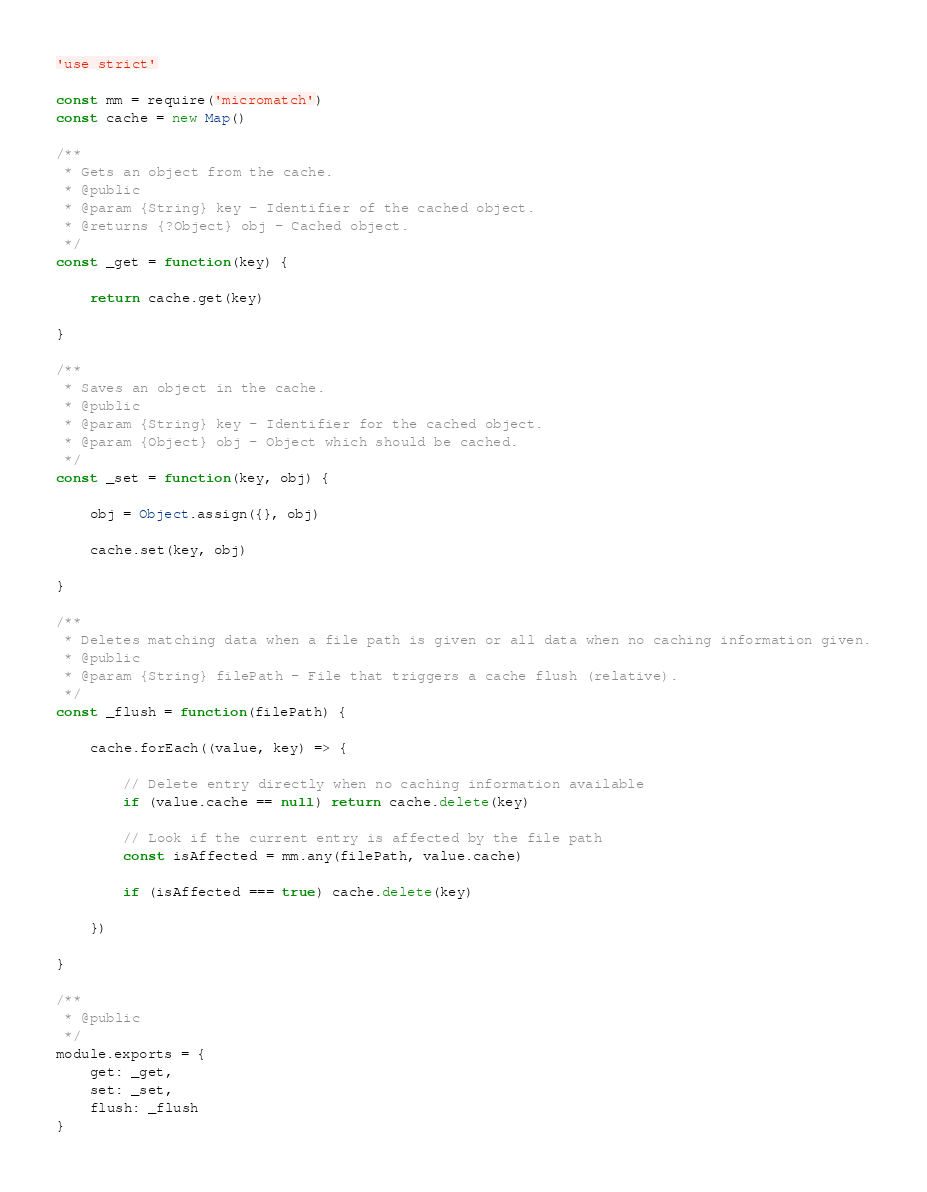Convert code to text. <code><loc_0><loc_0><loc_500><loc_500><_JavaScript_>'use strict'

const mm = require('micromatch')
const cache = new Map()

/**
 * Gets an object from the cache.
 * @public
 * @param {String} key - Identifier of the cached object.
 * @returns {?Object} obj - Cached object.
 */
const _get = function(key) {

	return cache.get(key)

}

/**
 * Saves an object in the cache.
 * @public
 * @param {String} key - Identifier for the cached object.
 * @param {Object} obj - Object which should be cached.
 */
const _set = function(key, obj) {

	obj = Object.assign({}, obj)

	cache.set(key, obj)

}

/**
 * Deletes matching data when a file path is given or all data when no caching information given.
 * @public
 * @param {String} filePath - File that triggers a cache flush (relative).
 */
const _flush = function(filePath) {

	cache.forEach((value, key) => {

		// Delete entry directly when no caching information available
		if (value.cache == null) return cache.delete(key)

		// Look if the current entry is affected by the file path
		const isAffected = mm.any(filePath, value.cache)

		if (isAffected === true) cache.delete(key)

	})

}

/**
 * @public
 */
module.exports = {
	get: _get,
	set: _set,
	flush: _flush
}</code> 